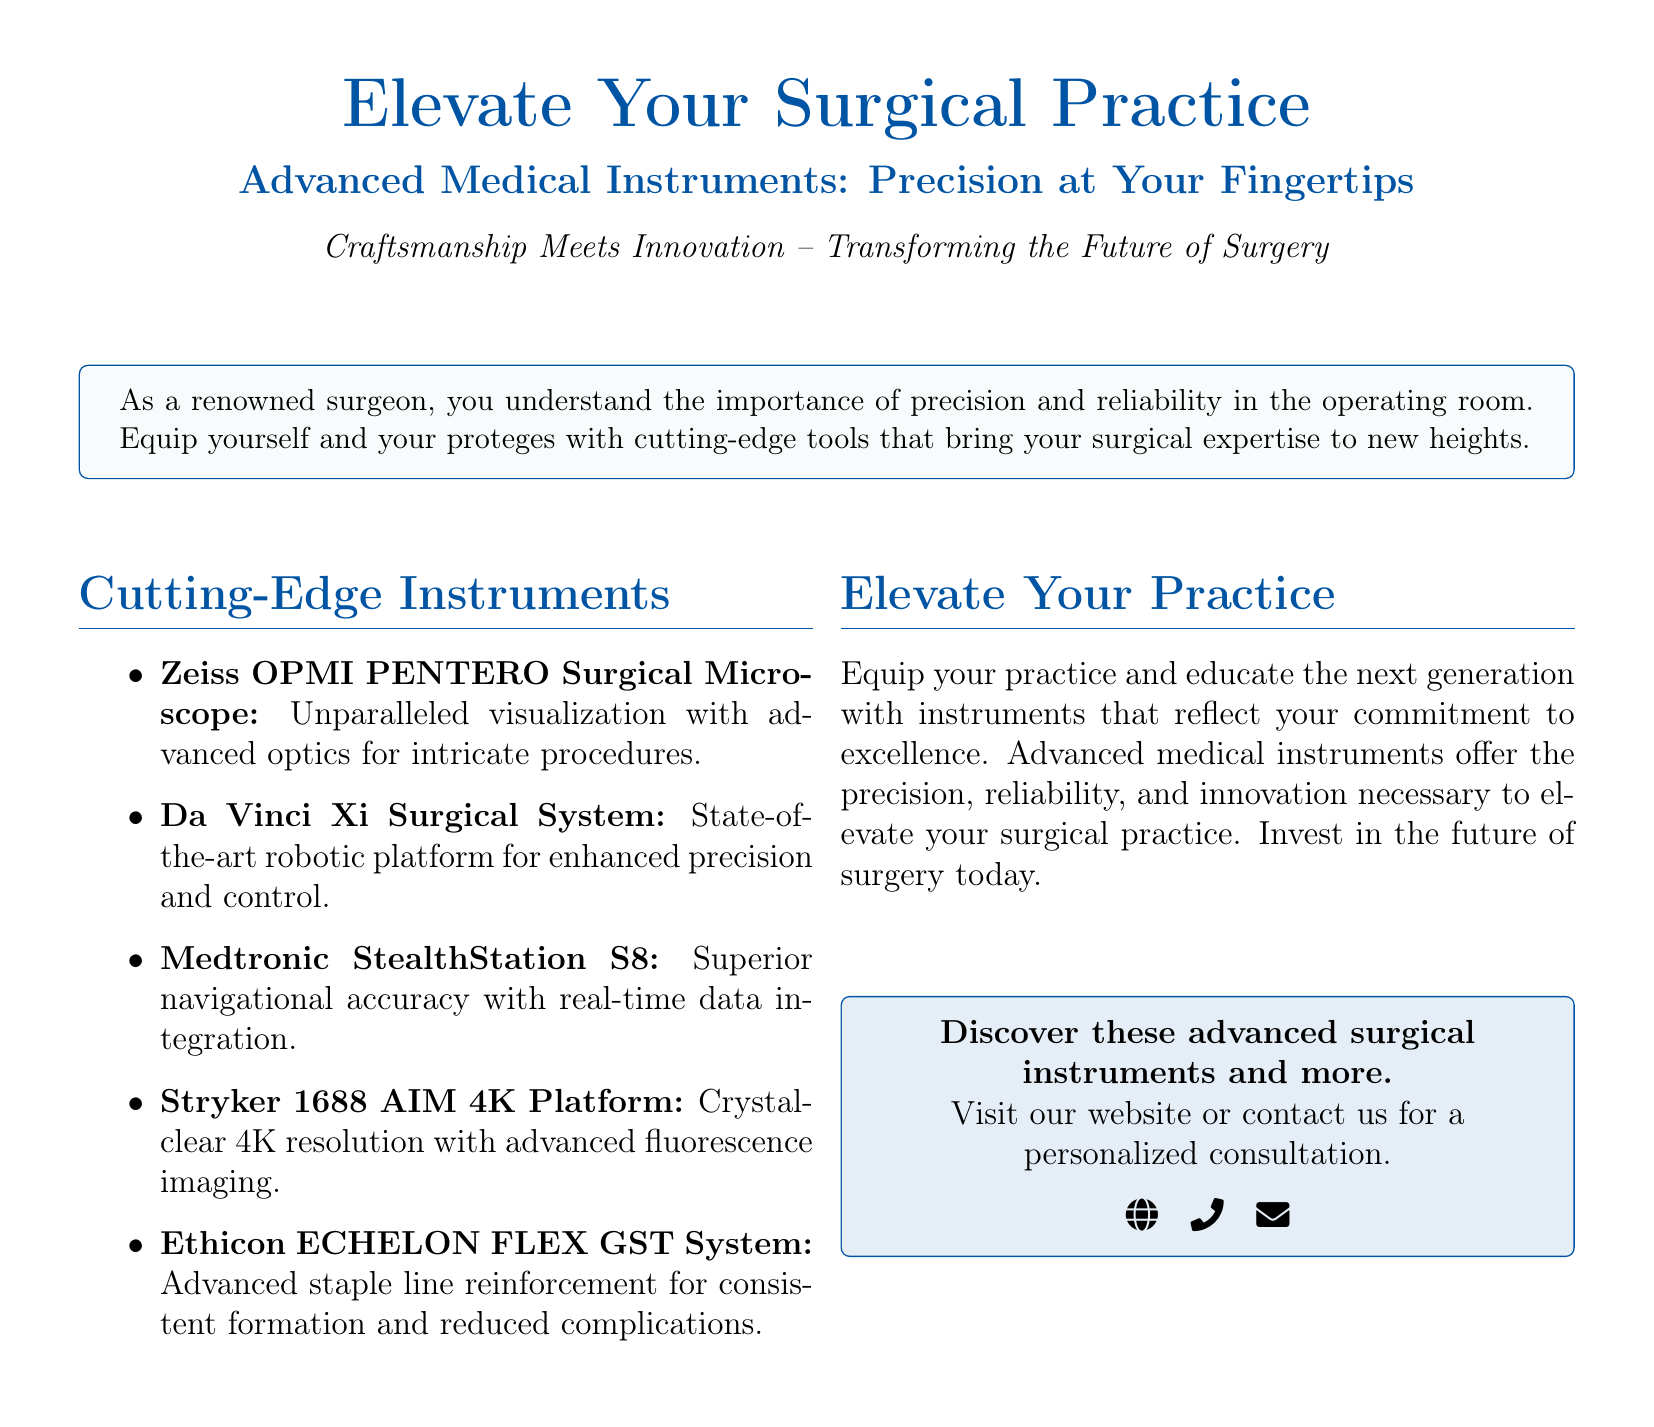what are the names of the instruments mentioned? The instruments listed in the document include the Zeiss OPMI PENTERO Surgical Microscope, Da Vinci Xi Surgical System, Medtronic StealthStation S8, Stryker 1688 AIM 4K Platform, and Ethicon ECHELON FLEX GST System.
Answer: Zeiss OPMI PENTERO Surgical Microscope, Da Vinci Xi Surgical System, Medtronic StealthStation S8, Stryker 1688 AIM 4K Platform, Ethicon ECHELON FLEX GST System what is the major benefit of the Da Vinci Xi Surgical System? The document highlights that the Da Vinci Xi Surgical System provides enhanced precision and control in surgical procedures.
Answer: Enhanced precision and control how does the Stryker 1688 AIM 4K Platform improve visualization? The Stryker 1688 AIM 4K Platform uses crystal-clear 4K resolution with advanced fluorescence imaging to enhance visualization.
Answer: Crystal-clear 4K resolution what is the color scheme used in the document? The document prominently features a color scheme that includes medblue and lightblue.
Answer: Medblue and lightblue what does the advertisement encourage surgeons to invest in? The advertisement encourages surgeons to invest in advanced medical instruments that provide precision, reliability, and innovation.
Answer: Advanced medical instruments what is the main purpose of the advertisement? The main purpose of the advertisement is to promote advanced medical instruments for enhancing surgical practice.
Answer: Promote advanced medical instruments what type of surgical practice does the document address? The document addresses precision surgery practices that require advanced medical instruments.
Answer: Precision surgery what is included in the contact section of the advertisement? The contact section of the advertisement includes a website, phone number, and email for personalized consultations.
Answer: Website, phone number, email 